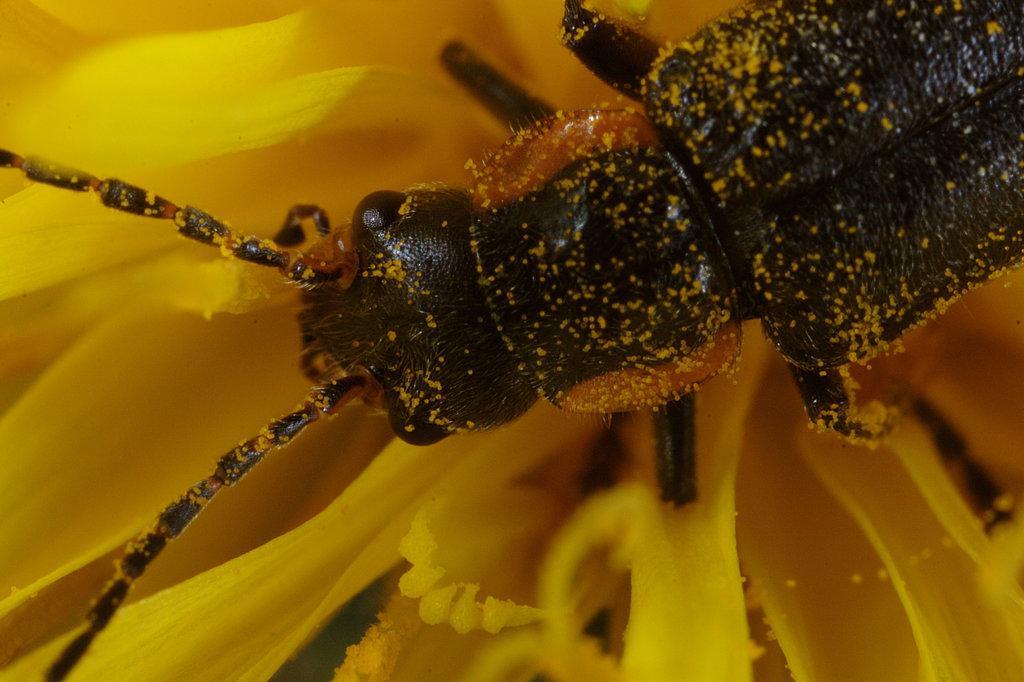Could you give a brief overview of what you see in this image? This is a yellow sunflower, on the yellow sunflower there is a insect. 